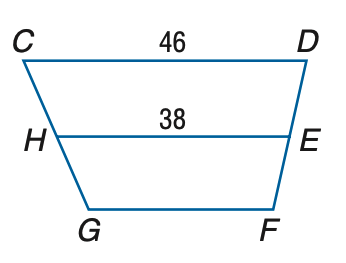Answer the mathemtical geometry problem and directly provide the correct option letter.
Question: Refer to trapezoid C D F G with median H E. Find G F.
Choices: A: 30 B: 32 C: 38 D: 46 A 